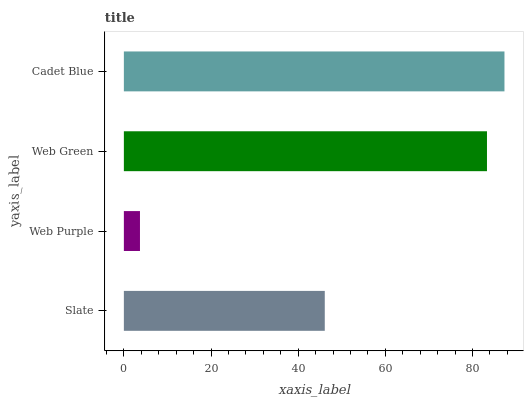Is Web Purple the minimum?
Answer yes or no. Yes. Is Cadet Blue the maximum?
Answer yes or no. Yes. Is Web Green the minimum?
Answer yes or no. No. Is Web Green the maximum?
Answer yes or no. No. Is Web Green greater than Web Purple?
Answer yes or no. Yes. Is Web Purple less than Web Green?
Answer yes or no. Yes. Is Web Purple greater than Web Green?
Answer yes or no. No. Is Web Green less than Web Purple?
Answer yes or no. No. Is Web Green the high median?
Answer yes or no. Yes. Is Slate the low median?
Answer yes or no. Yes. Is Web Purple the high median?
Answer yes or no. No. Is Web Green the low median?
Answer yes or no. No. 